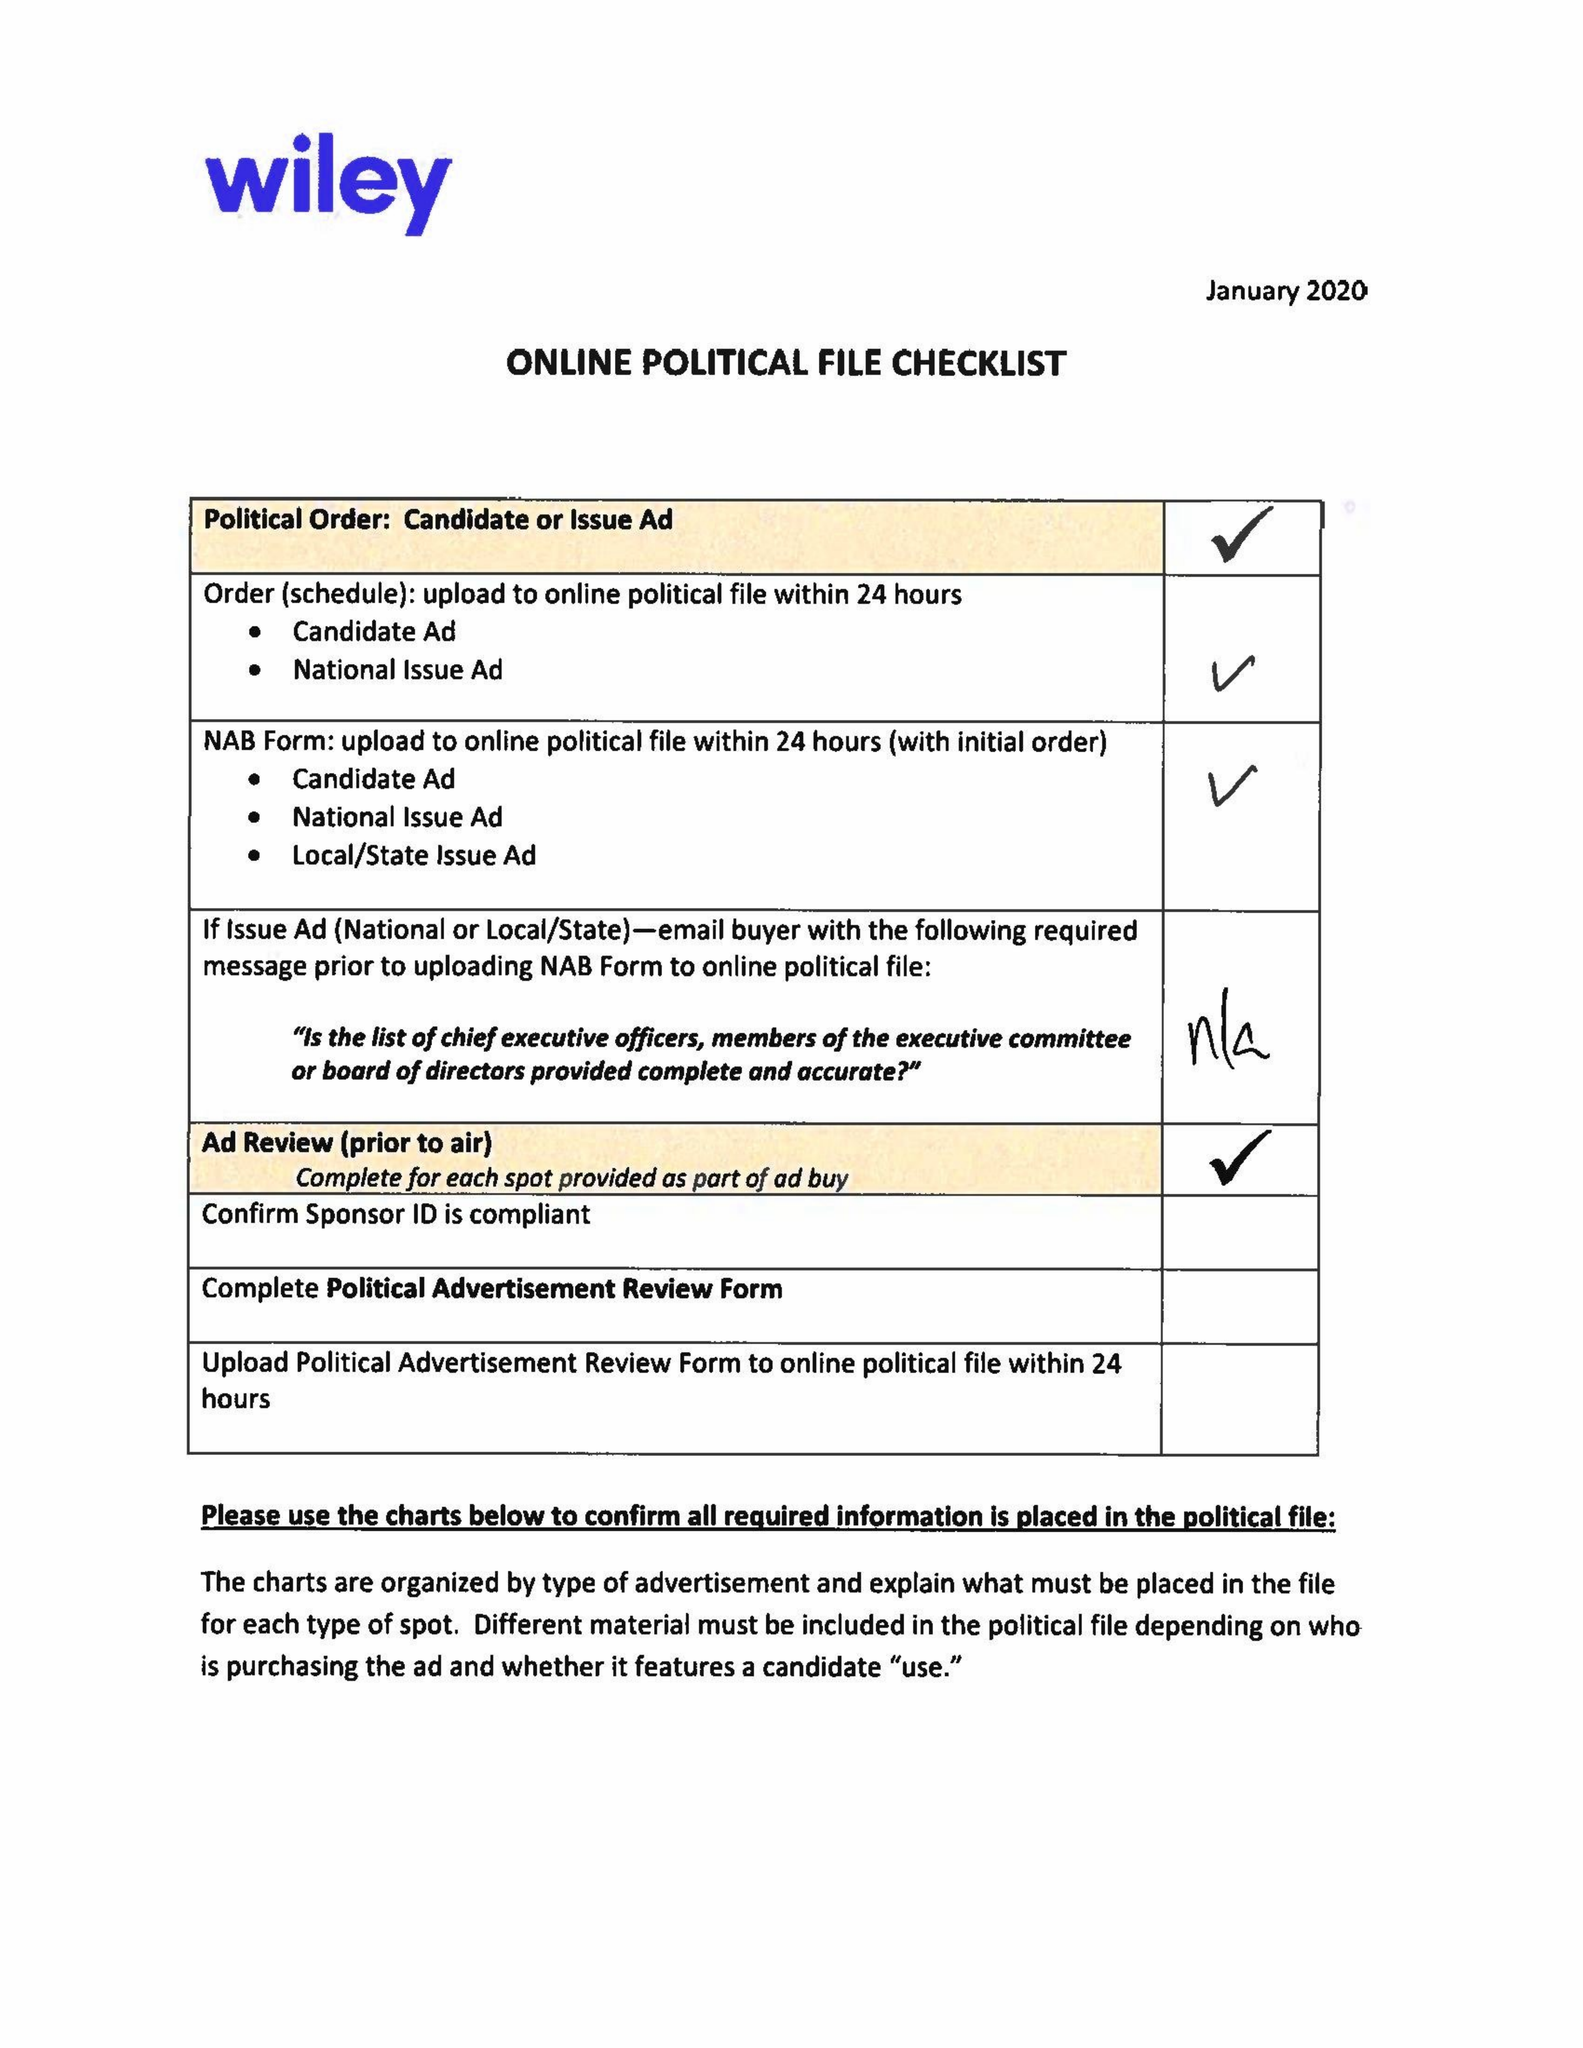What is the value for the contract_num?
Answer the question using a single word or phrase. 1522692 